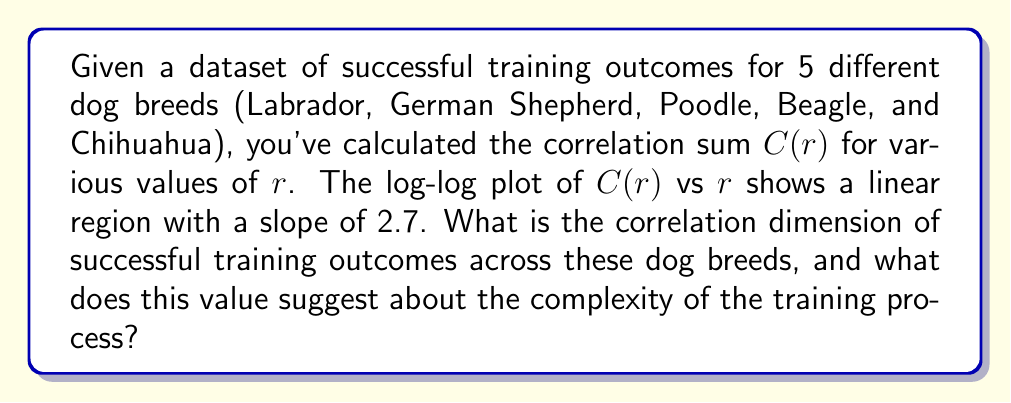Give your solution to this math problem. To solve this problem, we'll follow these steps:

1) The correlation dimension $D_2$ is defined as the slope of the linear region in the log-log plot of $C(r)$ vs $r$, where:

   $$D_2 = \lim_{r \to 0} \frac{\log C(r)}{\log r}$$

2) In practice, we estimate $D_2$ by calculating the slope of the linear region in the log-log plot.

3) Given information: The slope of the linear region is 2.7.

4) Therefore, the correlation dimension $D_2 = 2.7$.

5) Interpretation of the result:
   - A non-integer dimension suggests a fractal structure in the data.
   - $D_2 = 2.7$ indicates a relatively high complexity in the system.
   - This suggests that successful training outcomes across different dog breeds form a complex, multidimensional pattern that cannot be fully described by a simple 2D or 3D model.
   - The fractional part (0.7) implies some level of self-similarity or scaling in the data.

6) For dog trainers, this result suggests:
   - Training outcomes are influenced by multiple interacting factors.
   - There may be subtle patterns or relationships in training success that aren't immediately obvious.
   - A one-size-fits-all approach to training across breeds is unlikely to be optimal.
   - Trainers should be prepared to adapt their methods based on breed-specific characteristics and individual dog personalities.
Answer: $D_2 = 2.7$, indicating high complexity in training outcomes across breeds. 